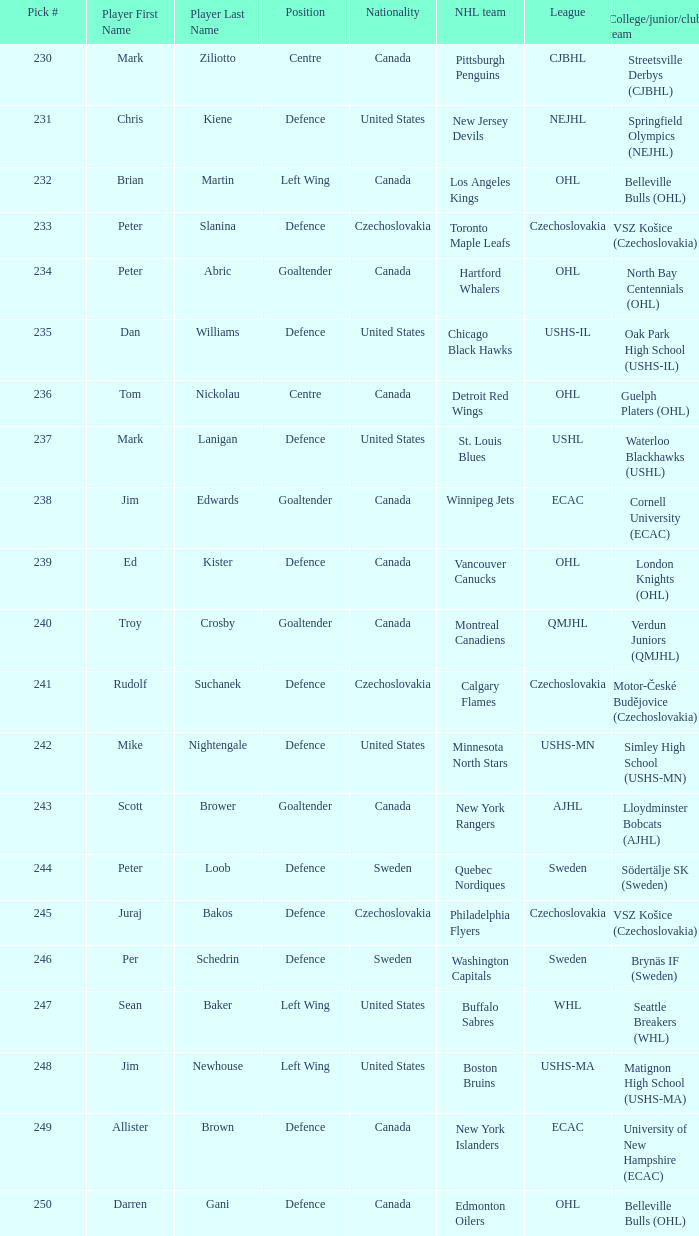What selection was the springfield olympics (nejhl)? 231.0. 